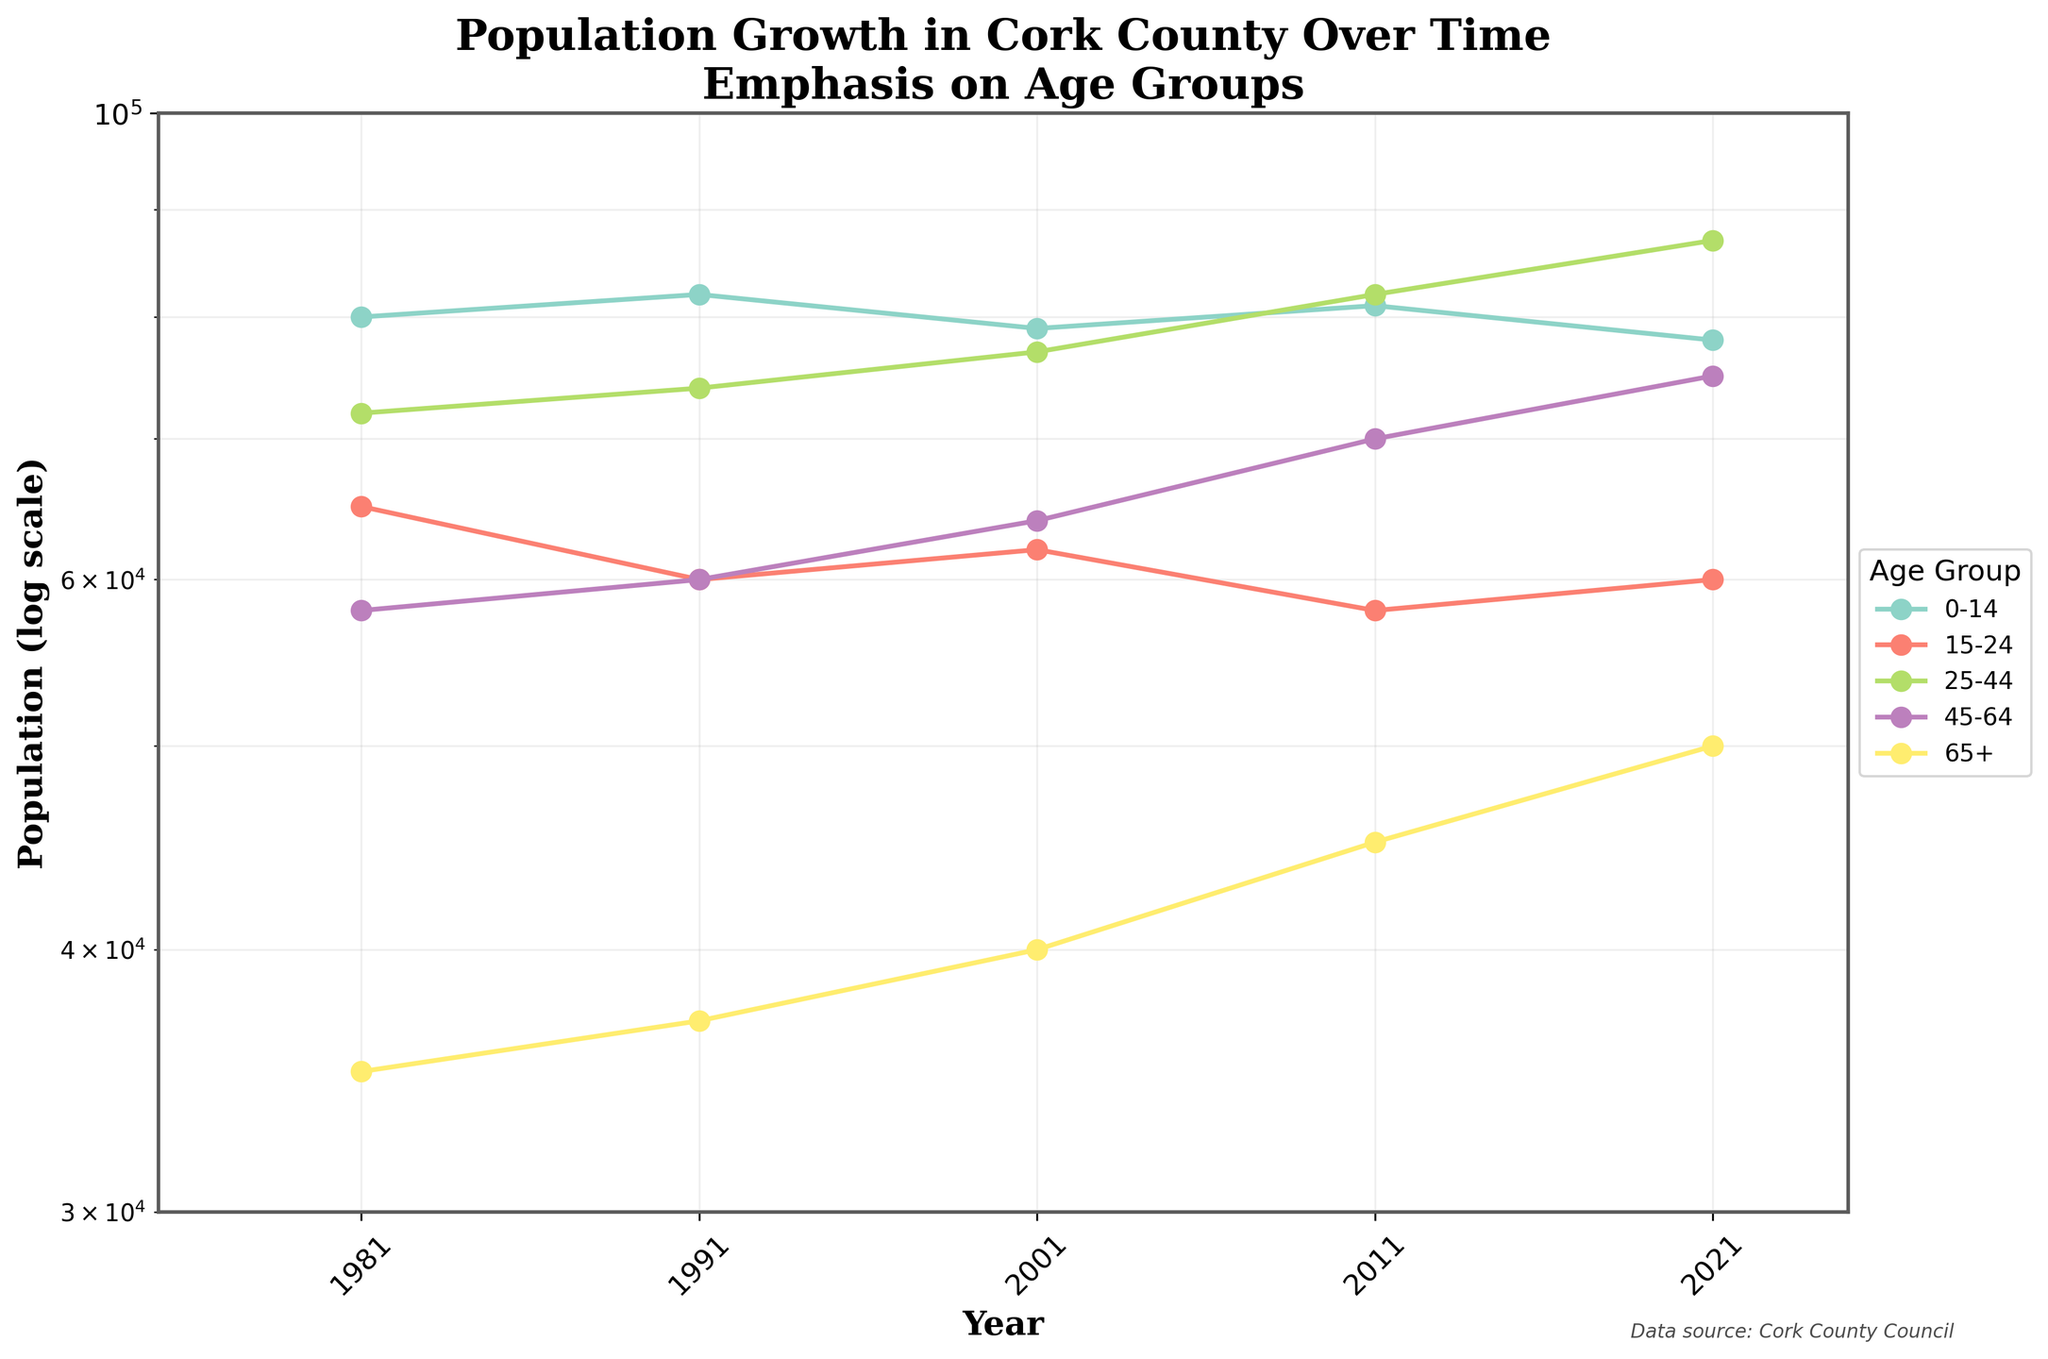What is the title of the plot? The title of the plot is at the top and reads "Population Growth in Cork County Over Time\nEmphasis on Age Groups".
Answer: "Population Growth in Cork County Over Time\nEmphasis on Age Groups" How is the population data displayed on the y-axis? The y-axis shows the population data on a log scale, which helps to manage large ranges in values.
Answer: Log scale Which age group has the highest population in 2021? By examining the 2021 data points, we see that the 25-44 age group has the highest position on the y-axis, indicating the highest population.
Answer: 25-44 Which age group had the smallest increase in population from 1981 to 2021? To determine this, look at each age group's population starting from 1981 and ending in 2021. The 0-14 age group shows the smallest change, from 80000 in 1981 to 78000 in 2021.
Answer: 0-14 In which year did the 65+ age group reach a population of more than 40000? By tracing the line for the 65+ age group, we see that it crossed the 40000 mark in 2001.
Answer: 2001 Which age group showed a population decline from 2011 to 2021? By observing the trend from 2011 to 2021, the 0-14 and 15-24 age groups show a decline in their respective lines.
Answer: 0-14 and 15-24 What trend can be seen in the population of the 25-44 age group over the years? The line for the 25-44 age group generally trends upwards from 1981 to 2021, indicating consistent population growth.
Answer: Upward trend Which age group has a consistent increase in population across all years? By tracing the lines for each age group, the 65+ age group shows a consistent upward trend across all years.
Answer: 65+ In what year did the 45-64 age group surpass the 25-44 age group? The 45-64 age group surpassed the 25-44 age group in the year 2011.
Answer: 2011 Compare the changes in population between the 0-14 and 65+ age groups from 1981 to 2021. The 0-14 age group started at 80000 in 1981 and ended at 78000 in 2021, showing a slight decrease. The 65+ age group started at 35000 in 1981 and ended at 50000 in 2021, showing a consistent increase. The net change for 0-14 is a decrease of 2000, while for 65+ it is an increase of 15000.
Answer: 0-14: -2000, 65+: +15000 